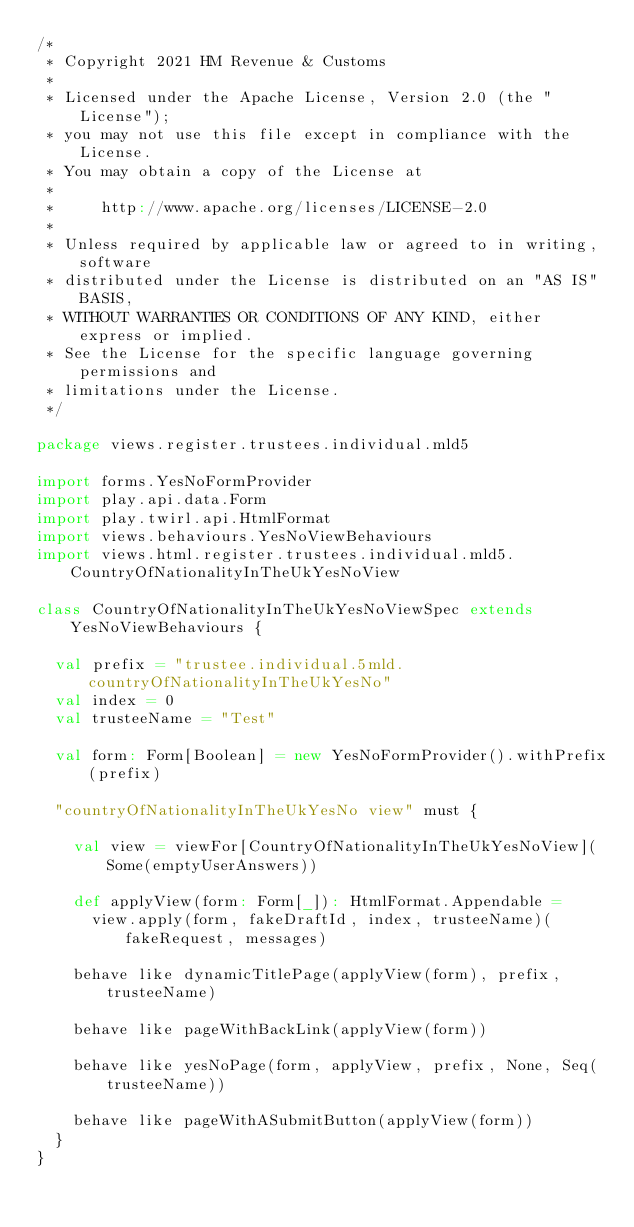<code> <loc_0><loc_0><loc_500><loc_500><_Scala_>/*
 * Copyright 2021 HM Revenue & Customs
 *
 * Licensed under the Apache License, Version 2.0 (the "License");
 * you may not use this file except in compliance with the License.
 * You may obtain a copy of the License at
 *
 *     http://www.apache.org/licenses/LICENSE-2.0
 *
 * Unless required by applicable law or agreed to in writing, software
 * distributed under the License is distributed on an "AS IS" BASIS,
 * WITHOUT WARRANTIES OR CONDITIONS OF ANY KIND, either express or implied.
 * See the License for the specific language governing permissions and
 * limitations under the License.
 */

package views.register.trustees.individual.mld5

import forms.YesNoFormProvider
import play.api.data.Form
import play.twirl.api.HtmlFormat
import views.behaviours.YesNoViewBehaviours
import views.html.register.trustees.individual.mld5.CountryOfNationalityInTheUkYesNoView

class CountryOfNationalityInTheUkYesNoViewSpec extends YesNoViewBehaviours {

  val prefix = "trustee.individual.5mld.countryOfNationalityInTheUkYesNo"
  val index = 0
  val trusteeName = "Test"

  val form: Form[Boolean] = new YesNoFormProvider().withPrefix(prefix)

  "countryOfNationalityInTheUkYesNo view" must {

    val view = viewFor[CountryOfNationalityInTheUkYesNoView](Some(emptyUserAnswers))

    def applyView(form: Form[_]): HtmlFormat.Appendable =
      view.apply(form, fakeDraftId, index, trusteeName)(fakeRequest, messages)

    behave like dynamicTitlePage(applyView(form), prefix, trusteeName)

    behave like pageWithBackLink(applyView(form))

    behave like yesNoPage(form, applyView, prefix, None, Seq(trusteeName))

    behave like pageWithASubmitButton(applyView(form))
  }
}
</code> 